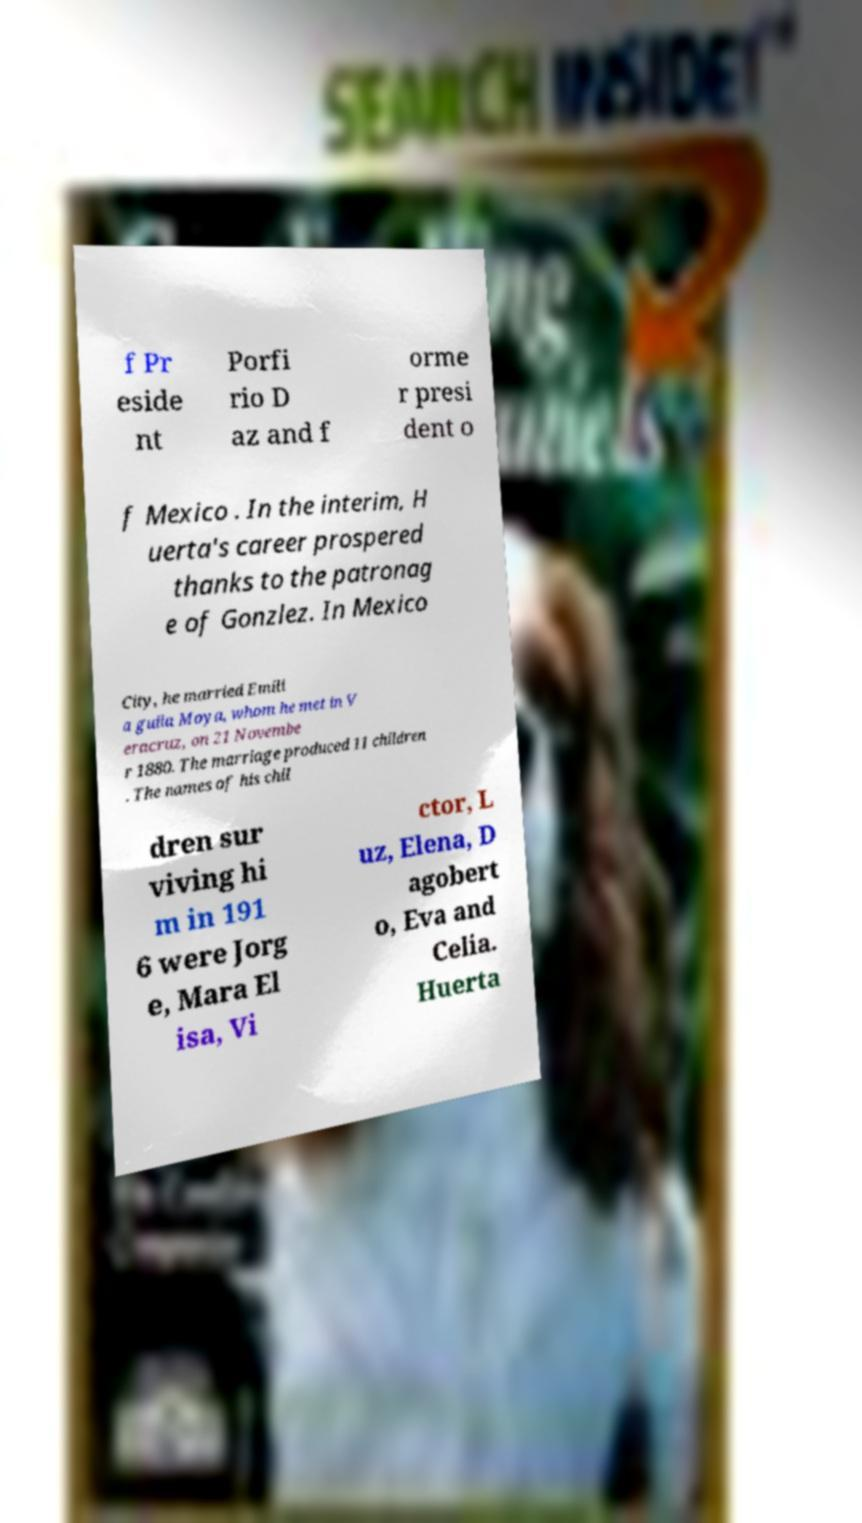Can you accurately transcribe the text from the provided image for me? f Pr eside nt Porfi rio D az and f orme r presi dent o f Mexico . In the interim, H uerta's career prospered thanks to the patronag e of Gonzlez. In Mexico City, he married Emili a guila Moya, whom he met in V eracruz, on 21 Novembe r 1880. The marriage produced 11 children . The names of his chil dren sur viving hi m in 191 6 were Jorg e, Mara El isa, Vi ctor, L uz, Elena, D agobert o, Eva and Celia. Huerta 